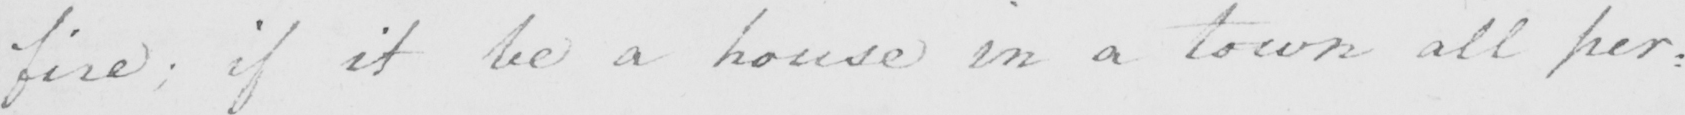Please transcribe the handwritten text in this image. fire ; if it be a house in a town all per : 